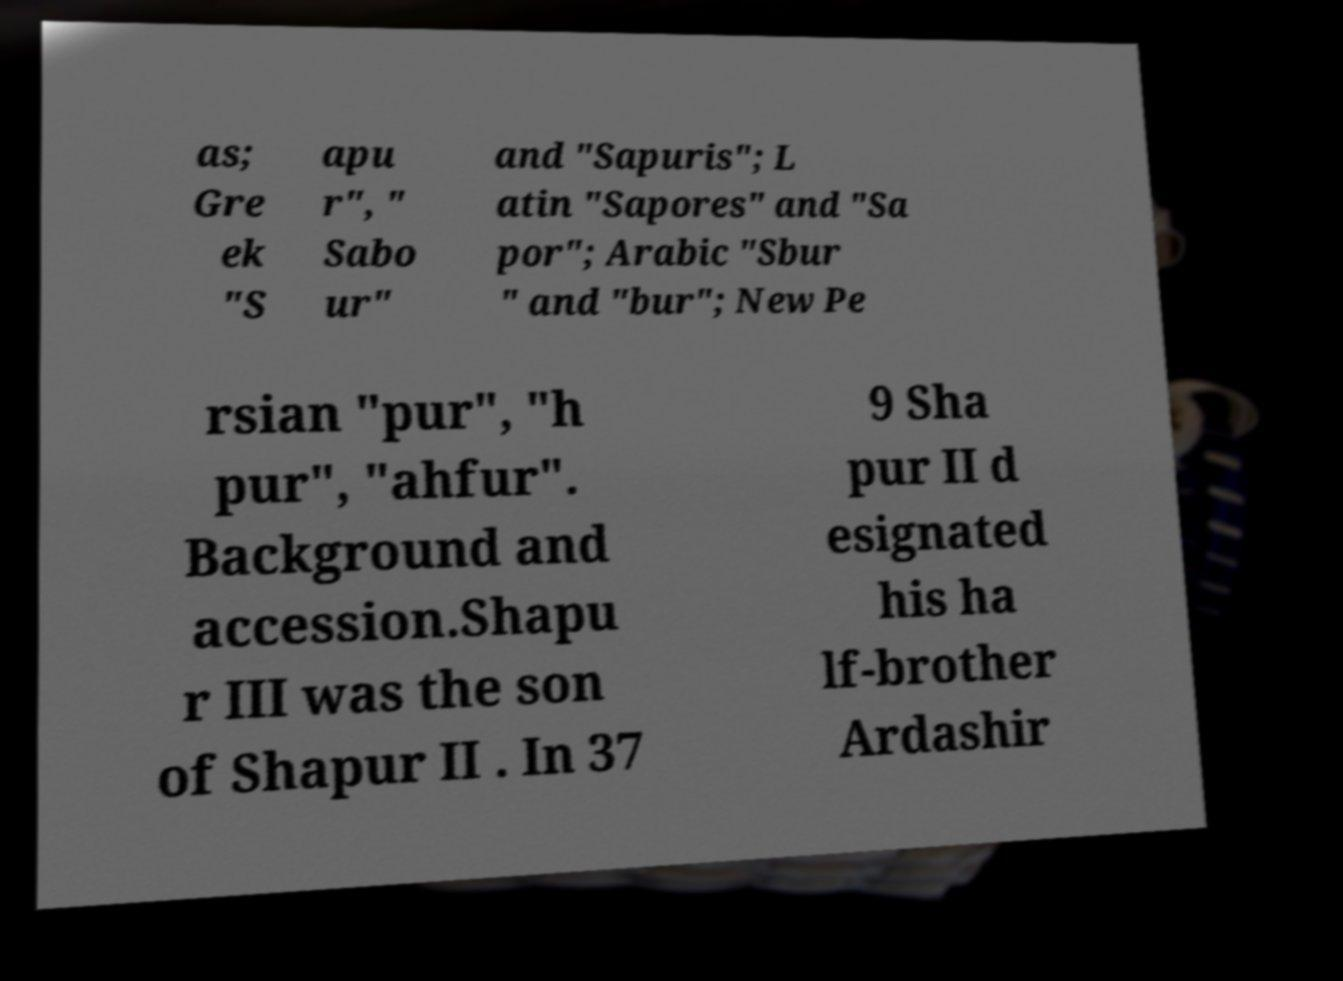Could you assist in decoding the text presented in this image and type it out clearly? as; Gre ek "S apu r", " Sabo ur" and "Sapuris"; L atin "Sapores" and "Sa por"; Arabic "Sbur " and "bur"; New Pe rsian "pur", "h pur", "ahfur". Background and accession.Shapu r III was the son of Shapur II . In 37 9 Sha pur II d esignated his ha lf-brother Ardashir 